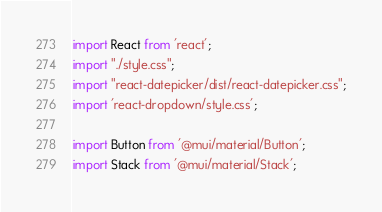Convert code to text. <code><loc_0><loc_0><loc_500><loc_500><_JavaScript_>import React from 'react';
import "./style.css";
import "react-datepicker/dist/react-datepicker.css";
import 'react-dropdown/style.css';

import Button from '@mui/material/Button';
import Stack from '@mui/material/Stack';
</code> 